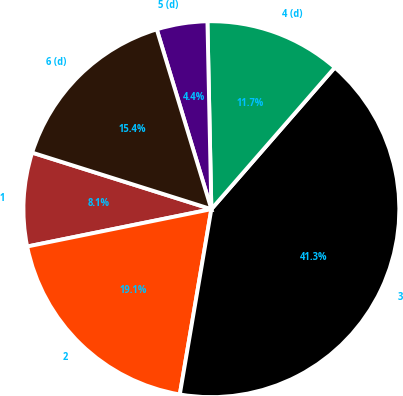<chart> <loc_0><loc_0><loc_500><loc_500><pie_chart><fcel>1<fcel>2<fcel>3<fcel>4 (d)<fcel>5 (d)<fcel>6 (d)<nl><fcel>8.05%<fcel>19.13%<fcel>41.28%<fcel>11.74%<fcel>4.36%<fcel>15.44%<nl></chart> 